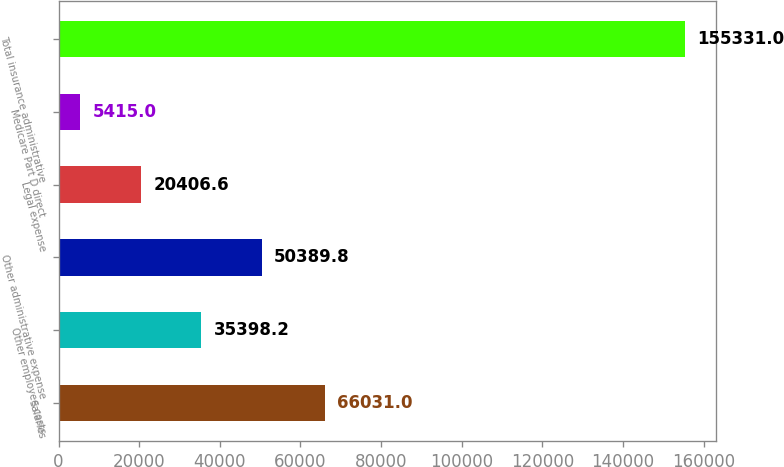Convert chart. <chart><loc_0><loc_0><loc_500><loc_500><bar_chart><fcel>Salaries<fcel>Other employee costs<fcel>Other administrative expense<fcel>Legal expense<fcel>Medicare Part D direct<fcel>Total insurance administrative<nl><fcel>66031<fcel>35398.2<fcel>50389.8<fcel>20406.6<fcel>5415<fcel>155331<nl></chart> 